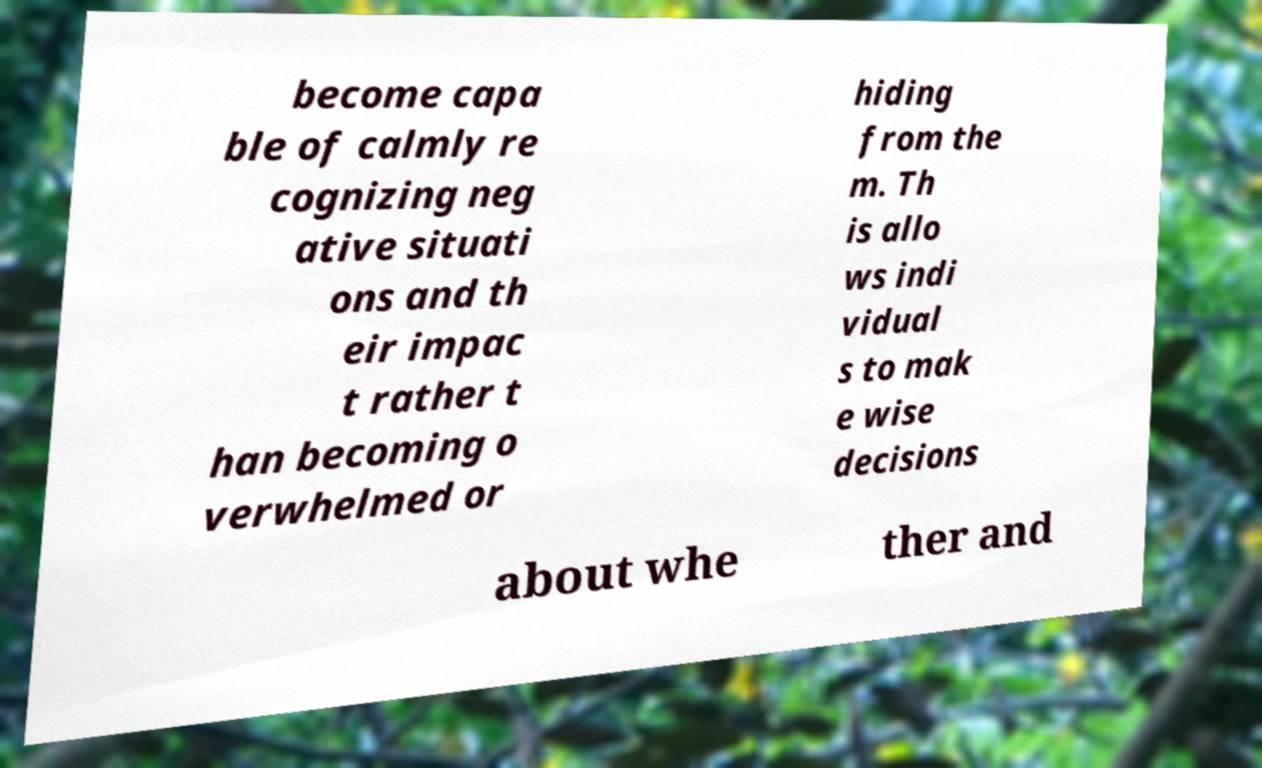Can you accurately transcribe the text from the provided image for me? become capa ble of calmly re cognizing neg ative situati ons and th eir impac t rather t han becoming o verwhelmed or hiding from the m. Th is allo ws indi vidual s to mak e wise decisions about whe ther and 